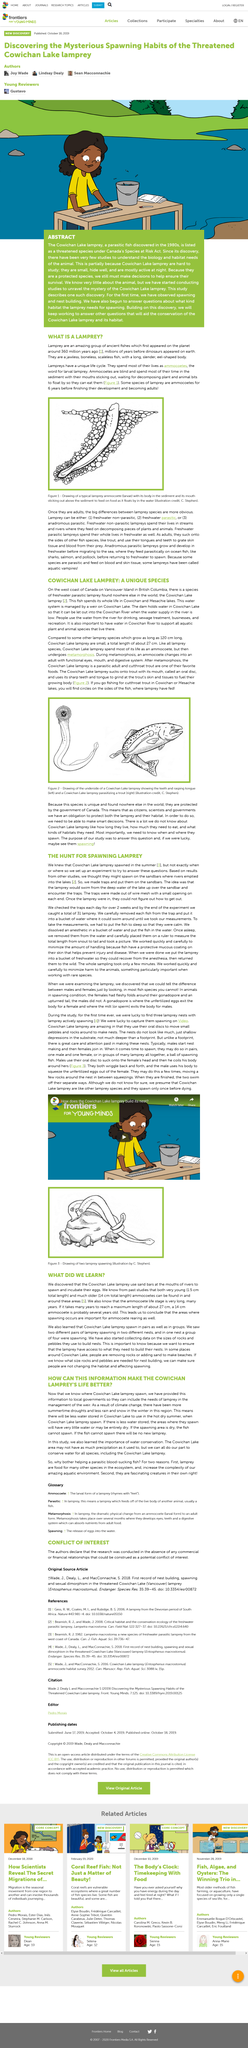Specify some key components in this picture. Cowichan Lake is located on Vancouver Island in British Columbia, Canada, and it is a well-known tourist destination. A total of three lamprey nests were discovered. Figure 3 presents a drawing of two lampreys, clearly depicting their elongated bodies and cylindrical tail fins. Lamprey are an ancient group of fish that have been on the planet for millions of years and are considered an amazing species due to their unique characteristics and adaptations. Freshwater non-parasitic lampreys feed on decomposing pieces of plants and animals that have been present in freshwater environments. 